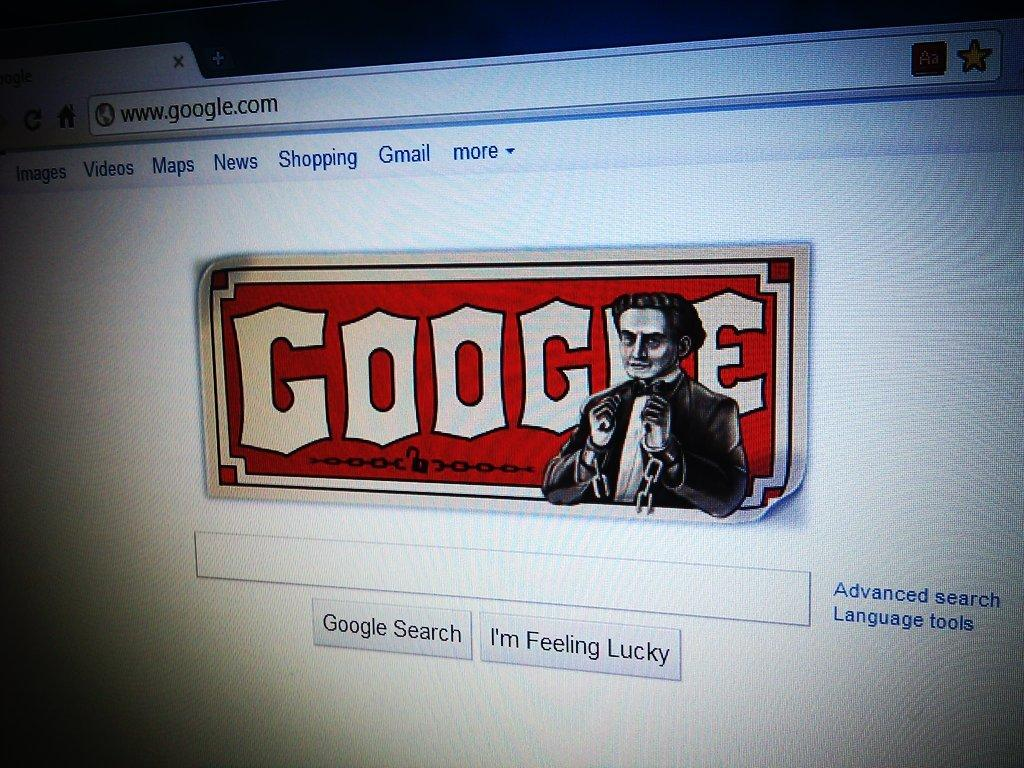Provide a one-sentence caption for the provided image. Screen showing a website for Google on it. 